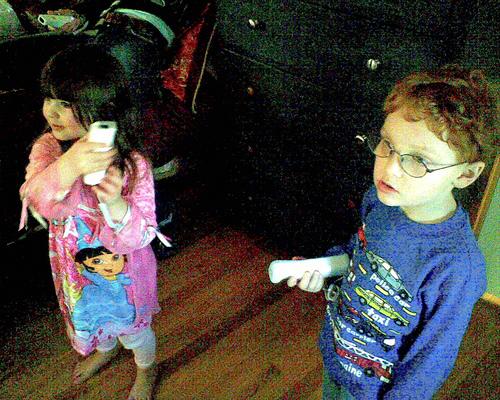What are the kids playing?
Answer briefly. Wii. What are the children's names?
Be succinct. Kate and pete. Are the children happy?
Concise answer only. Yes. 